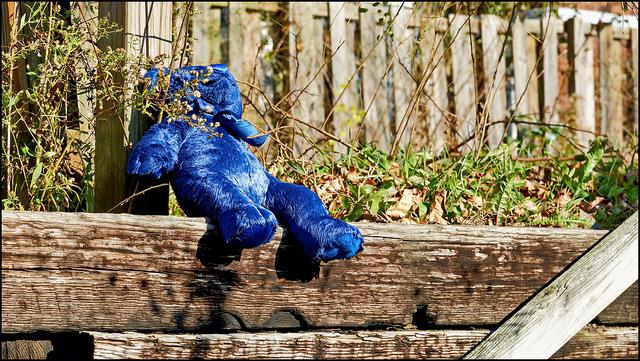Is the teddy bear sitting on a bench?
Give a very brief answer. No. Is this bear blue?
Give a very brief answer. Yes. Is the teddy bear indoors?
Quick response, please. No. 